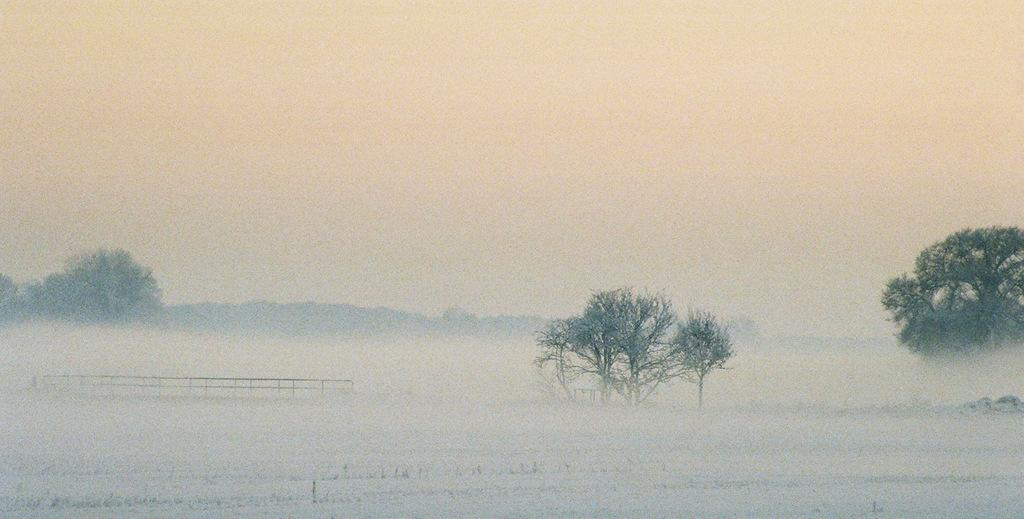What type of vegetation can be seen in the image? There are trees in the image. What is covering the ground in the image? There is snow visible in the image. What type of barrier is present in the image? There is a fence in the image. What type of geographical feature can be seen in the distance? There are mountains in the image. What is visible in the background of the image? The sky is visible in the background of the image. What type of appliance can be seen plugged into the fence in the image? There is no appliance present in the image; it features trees, snow, a fence, mountains, and the sky. What sign is visible on the trees in the image? There are no signs visible on the trees in the image. 